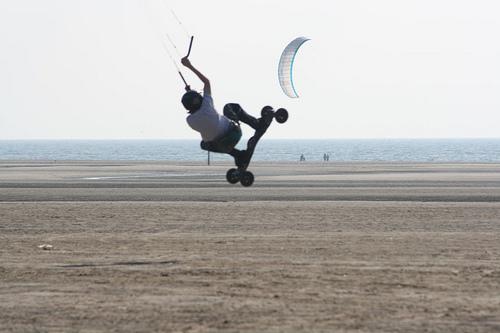How is he in the air?
Short answer required. Windsurfing. Is the man at the beach?
Concise answer only. Yes. Why is he in the air?
Concise answer only. Parasailing. 